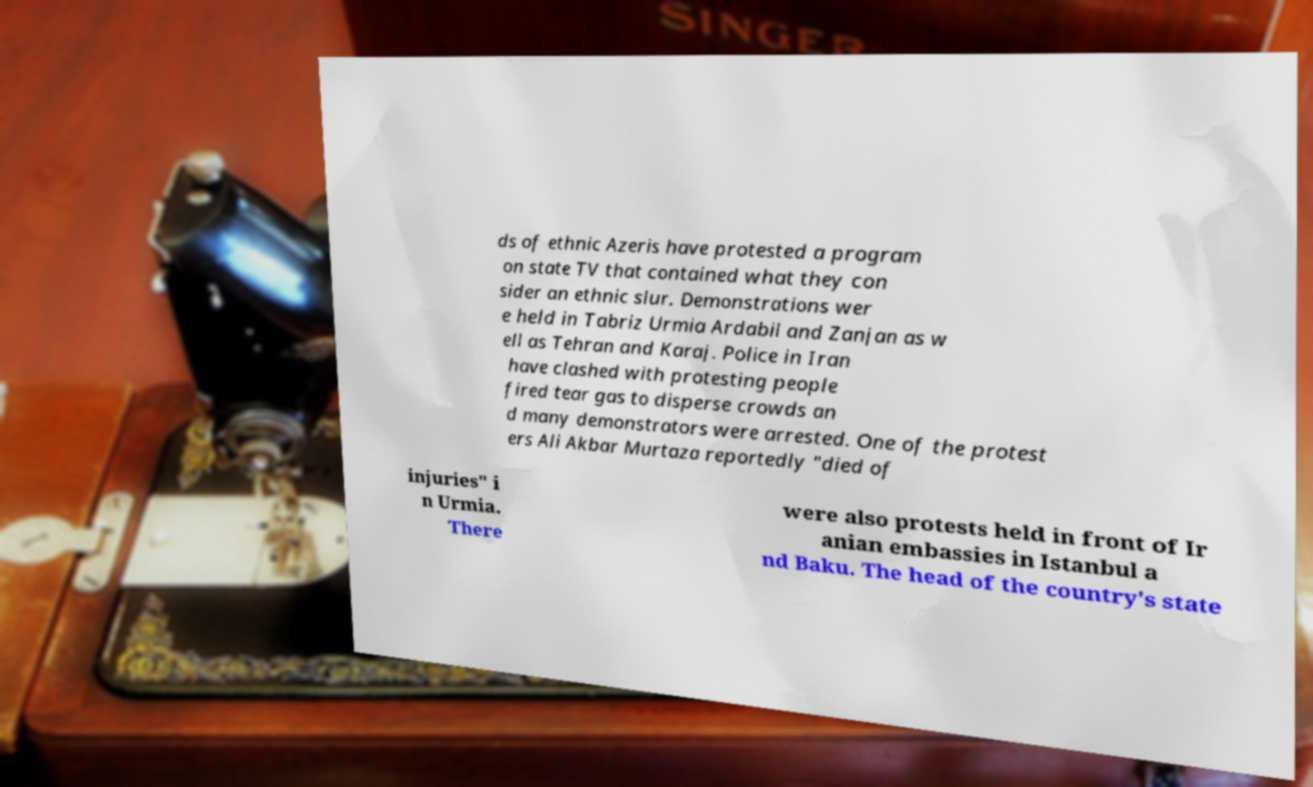Please identify and transcribe the text found in this image. ds of ethnic Azeris have protested a program on state TV that contained what they con sider an ethnic slur. Demonstrations wer e held in Tabriz Urmia Ardabil and Zanjan as w ell as Tehran and Karaj. Police in Iran have clashed with protesting people fired tear gas to disperse crowds an d many demonstrators were arrested. One of the protest ers Ali Akbar Murtaza reportedly "died of injuries" i n Urmia. There were also protests held in front of Ir anian embassies in Istanbul a nd Baku. The head of the country's state 